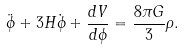Convert formula to latex. <formula><loc_0><loc_0><loc_500><loc_500>\ddot { \phi } + 3 H \dot { \phi } + \frac { d V } { d \phi } = \frac { 8 \pi G } { 3 } \rho .</formula> 